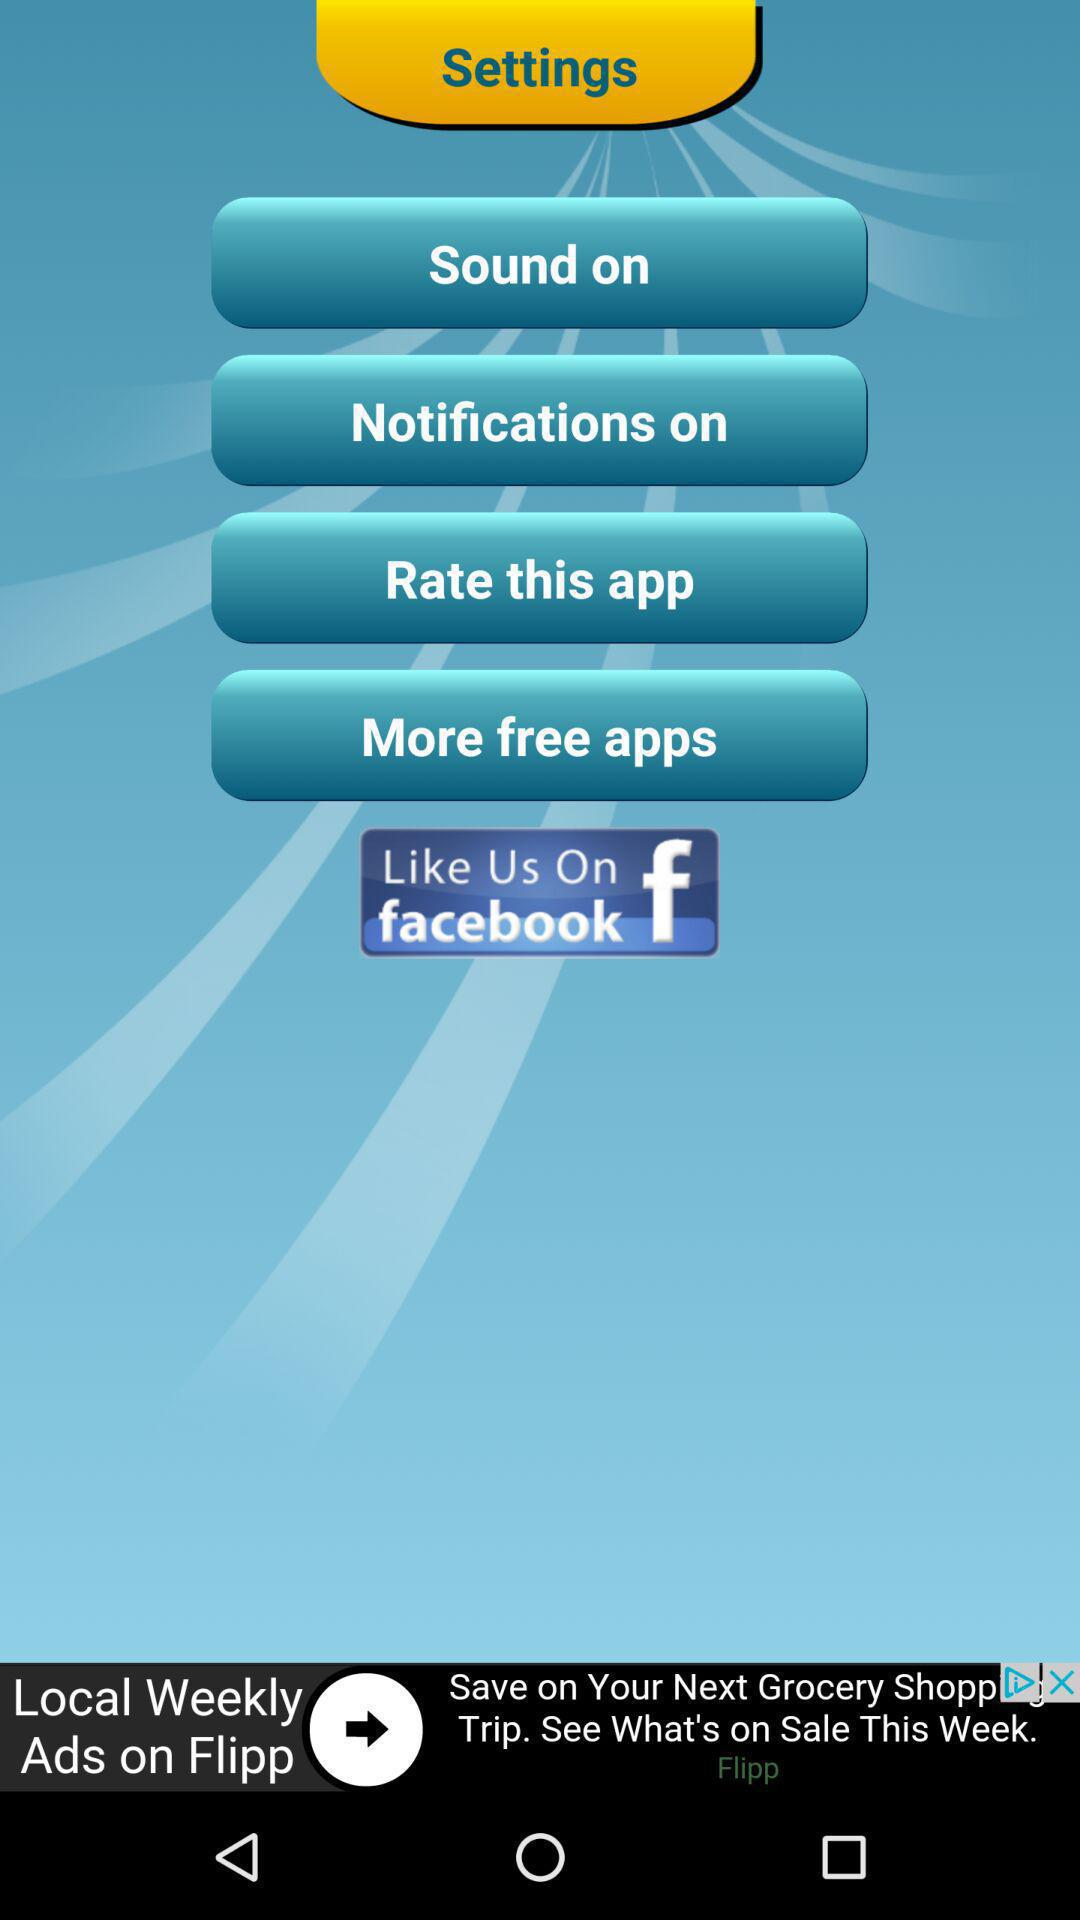Which social media platform can I use to like this application? You can use "facebook" to like this application. 